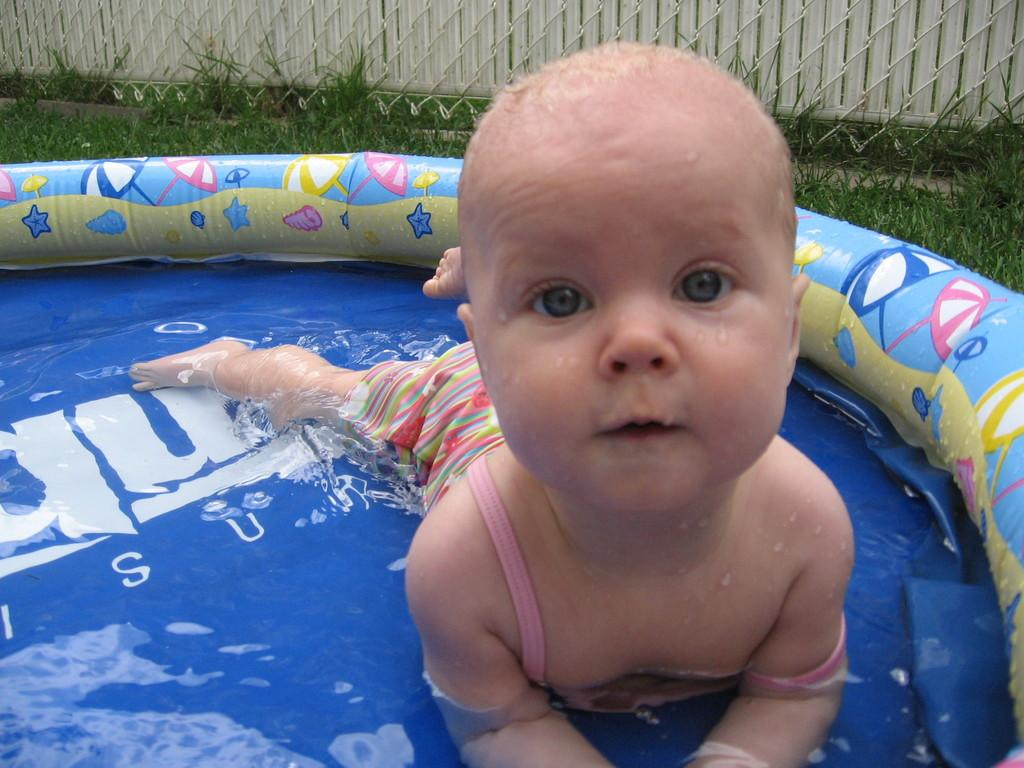What is the main subject in the image? There is a kid in a water tub. Can you describe the surroundings of the kid? The ground has greenery. What type of business is being conducted in the image? There is no indication of any business activity in the image; it primarily features a kid in a water tub and greenery on the ground. 